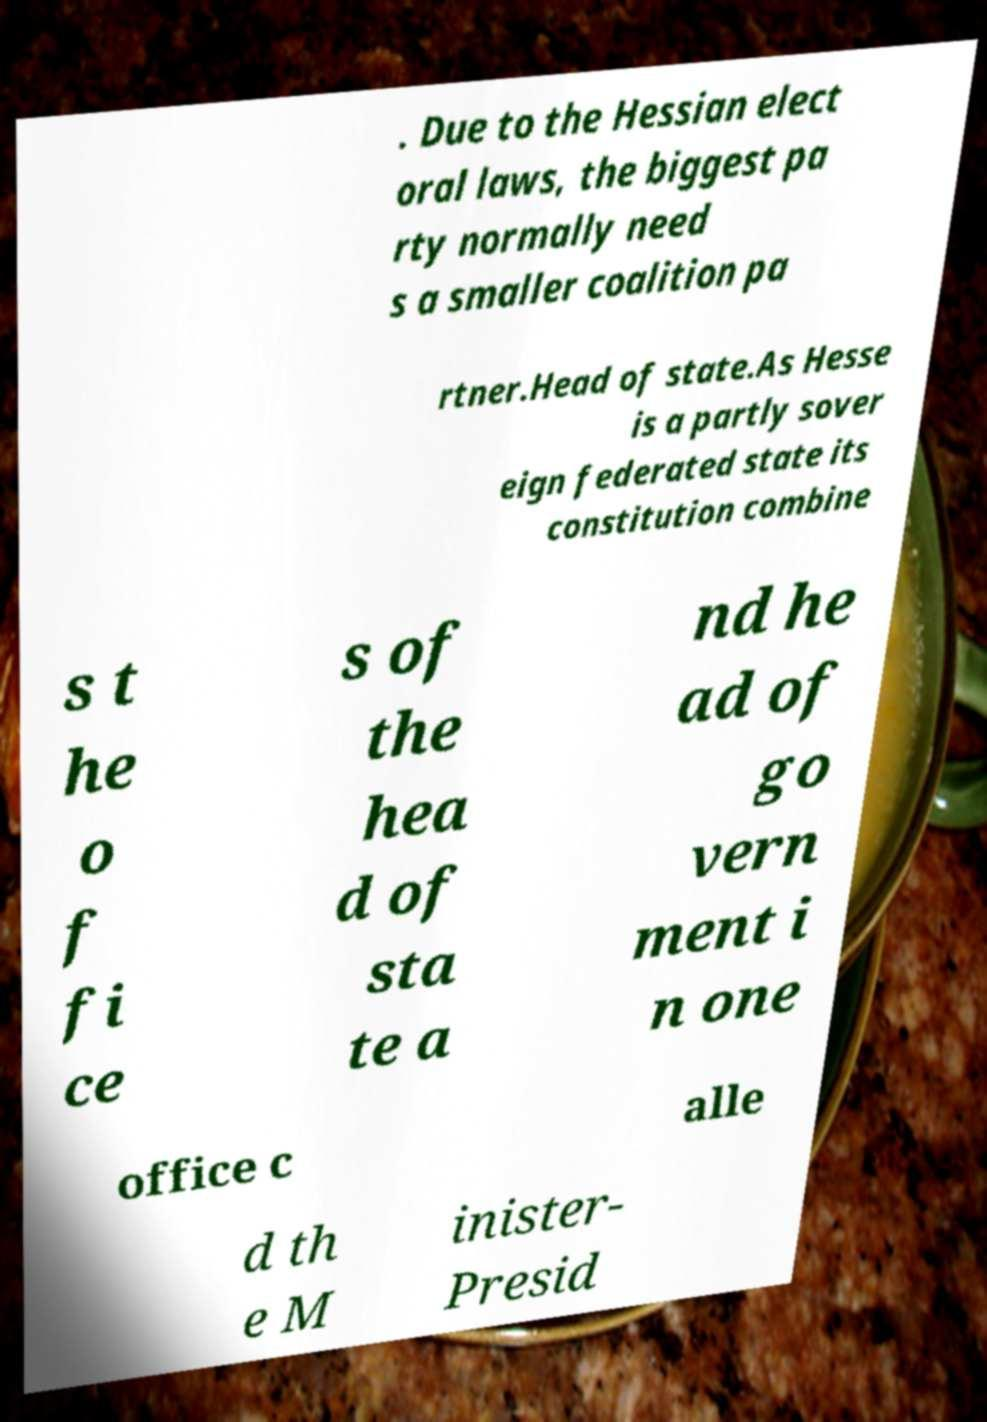Please read and relay the text visible in this image. What does it say? . Due to the Hessian elect oral laws, the biggest pa rty normally need s a smaller coalition pa rtner.Head of state.As Hesse is a partly sover eign federated state its constitution combine s t he o f fi ce s of the hea d of sta te a nd he ad of go vern ment i n one office c alle d th e M inister- Presid 